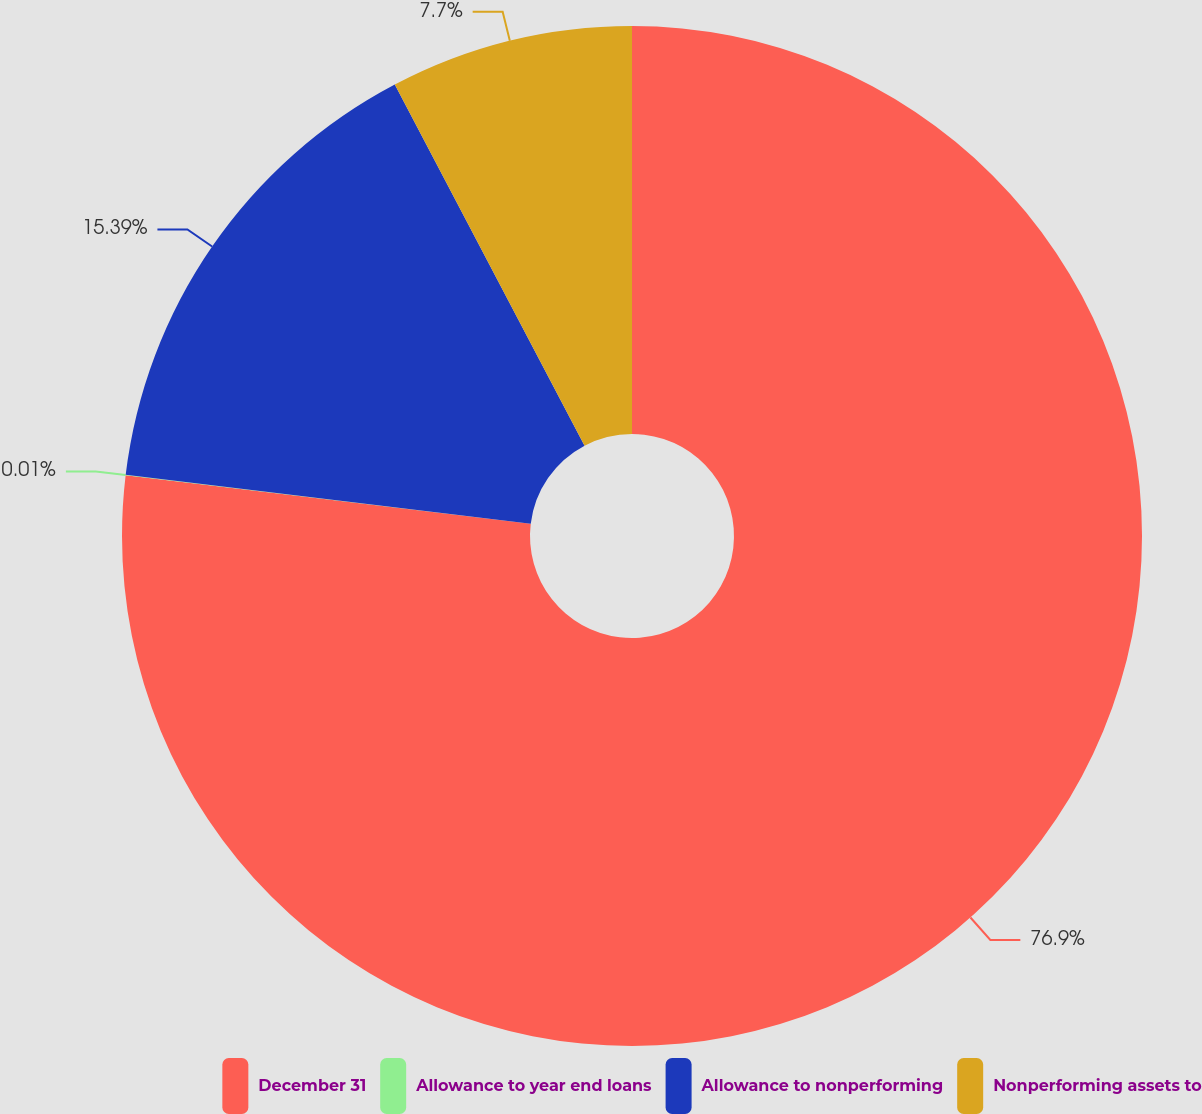Convert chart to OTSL. <chart><loc_0><loc_0><loc_500><loc_500><pie_chart><fcel>December 31<fcel>Allowance to year end loans<fcel>Allowance to nonperforming<fcel>Nonperforming assets to<nl><fcel>76.91%<fcel>0.01%<fcel>15.39%<fcel>7.7%<nl></chart> 